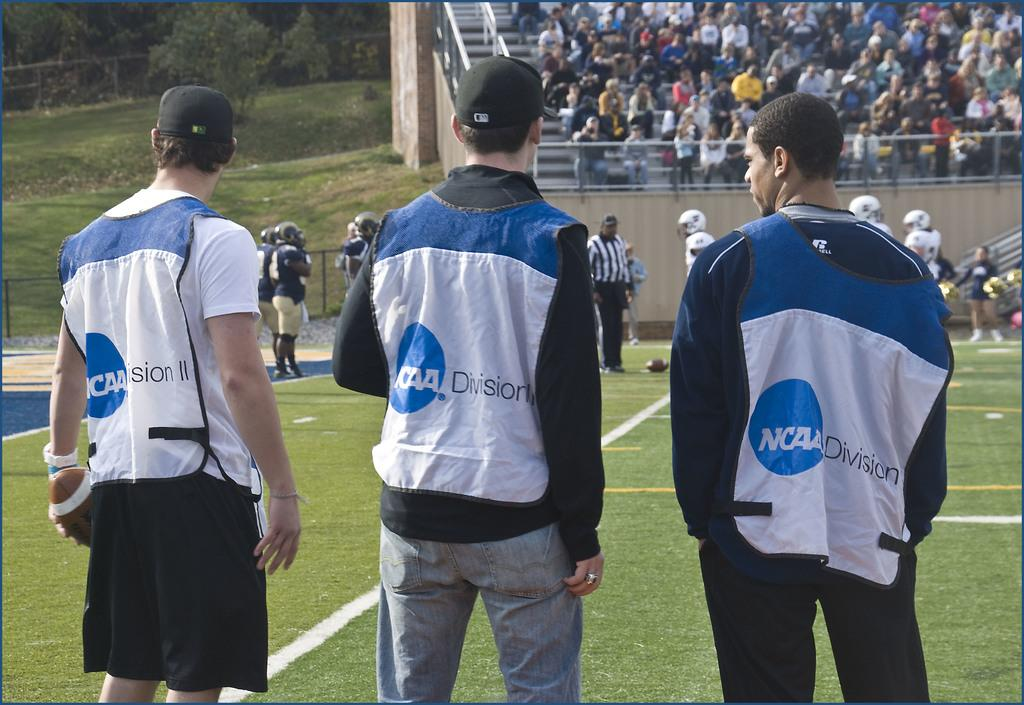<image>
Summarize the visual content of the image. Men wearing vests that says NCAA Division standing and watching a game. 